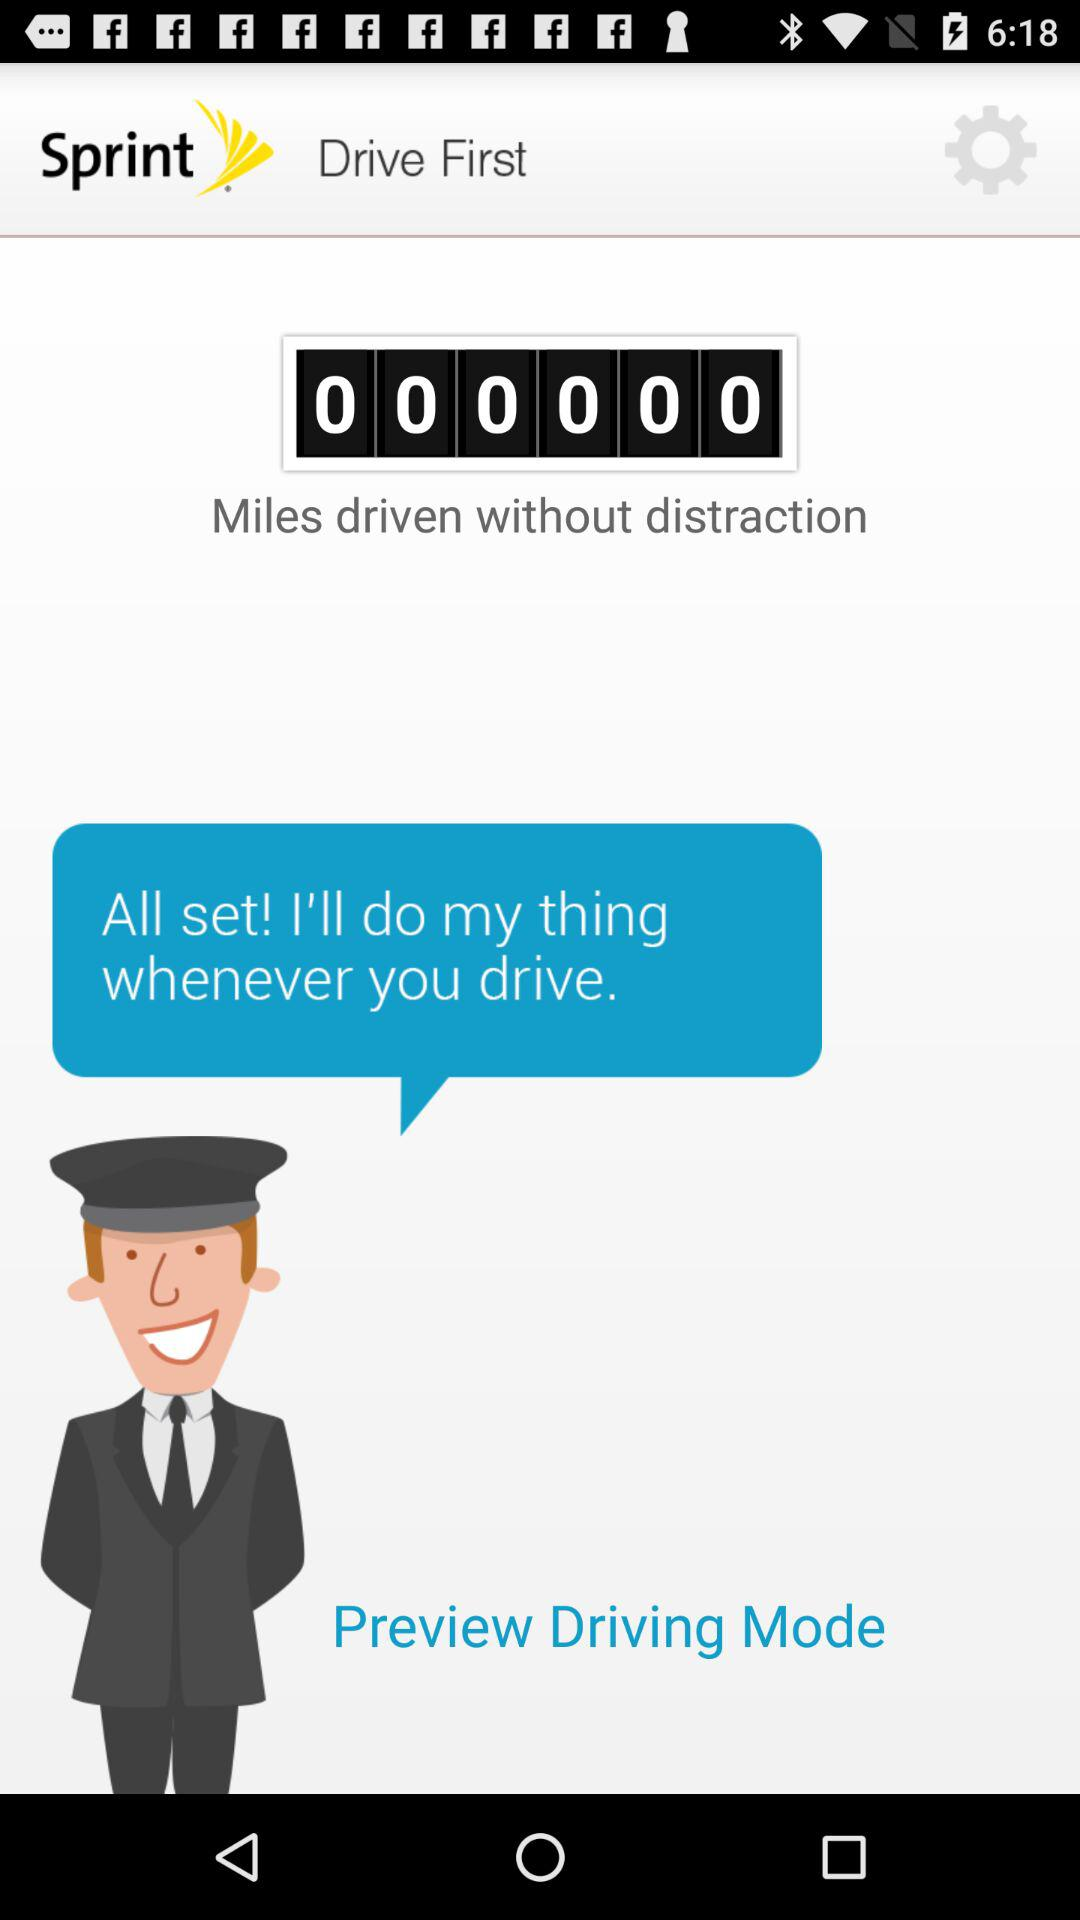What is the application name? The application name is "Sprint". 